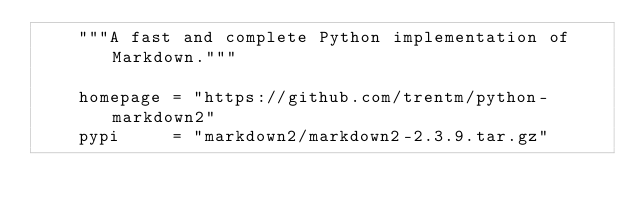<code> <loc_0><loc_0><loc_500><loc_500><_Python_>    """A fast and complete Python implementation of Markdown."""

    homepage = "https://github.com/trentm/python-markdown2"
    pypi     = "markdown2/markdown2-2.3.9.tar.gz"
</code> 